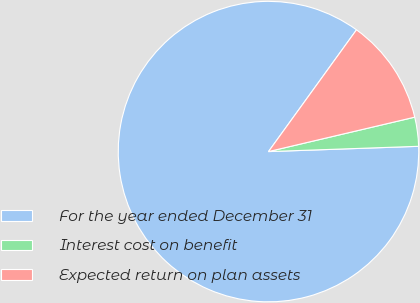Convert chart. <chart><loc_0><loc_0><loc_500><loc_500><pie_chart><fcel>For the year ended December 31<fcel>Interest cost on benefit<fcel>Expected return on plan assets<nl><fcel>85.53%<fcel>3.12%<fcel>11.36%<nl></chart> 